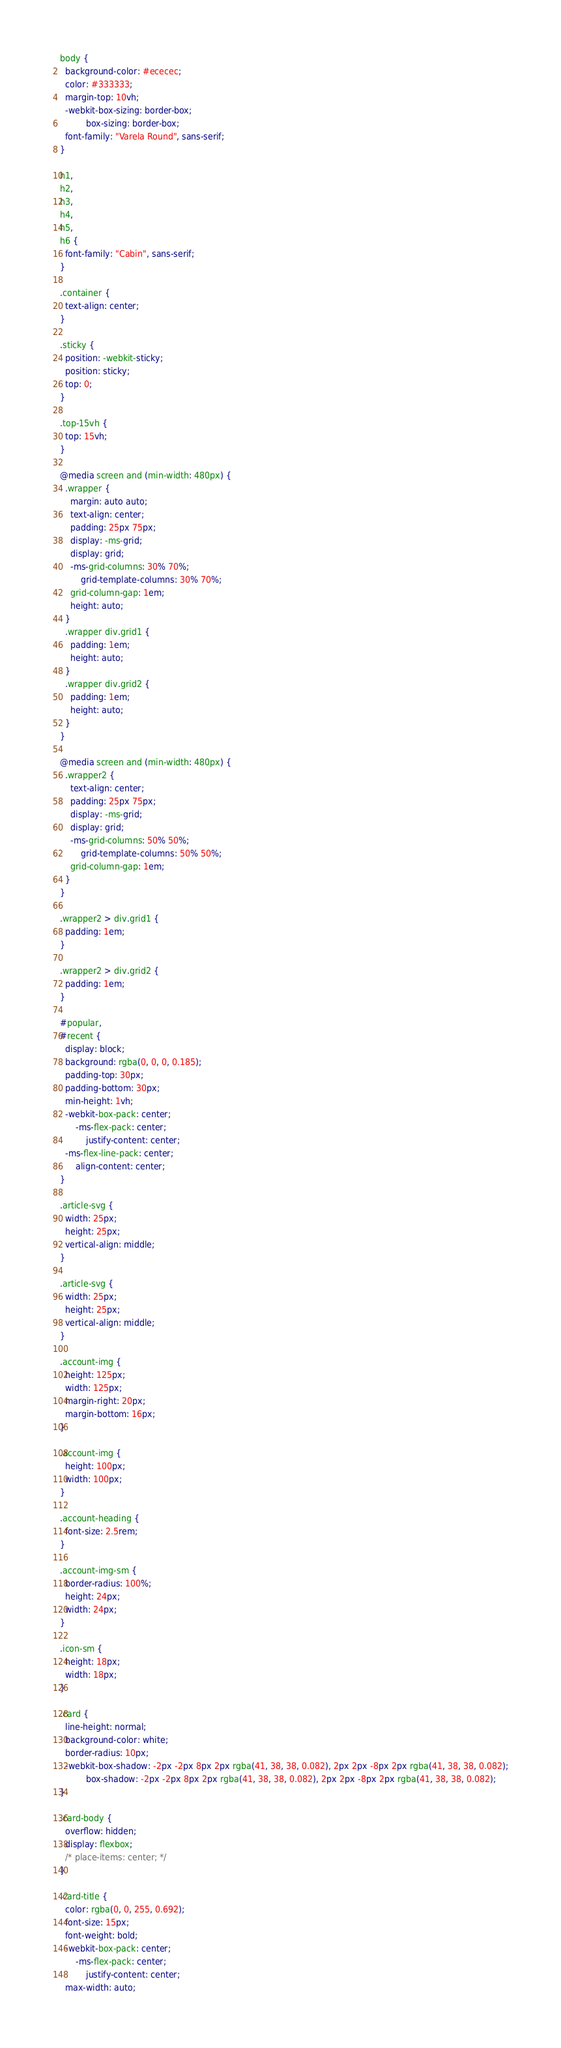Convert code to text. <code><loc_0><loc_0><loc_500><loc_500><_CSS_>body {
  background-color: #ececec;
  color: #333333;
  margin-top: 10vh;
  -webkit-box-sizing: border-box;
          box-sizing: border-box;
  font-family: "Varela Round", sans-serif;
}

h1,
h2,
h3,
h4,
h5,
h6 {
  font-family: "Cabin", sans-serif;
}

.container {
  text-align: center;
}

.sticky {
  position: -webkit-sticky;
  position: sticky;
  top: 0;
}

.top-15vh {
  top: 15vh;
}

@media screen and (min-width: 480px) {
  .wrapper {
    margin: auto auto;
    text-align: center;
    padding: 25px 75px;
    display: -ms-grid;
    display: grid;
    -ms-grid-columns: 30% 70%;
        grid-template-columns: 30% 70%;
    grid-column-gap: 1em;
    height: auto;
  }
  .wrapper div.grid1 {
    padding: 1em;
    height: auto;
  }
  .wrapper div.grid2 {
    padding: 1em;
    height: auto;
  }
}

@media screen and (min-width: 480px) {
  .wrapper2 {
    text-align: center;
    padding: 25px 75px;
    display: -ms-grid;
    display: grid;
    -ms-grid-columns: 50% 50%;
        grid-template-columns: 50% 50%;
    grid-column-gap: 1em;
  }
}

.wrapper2 > div.grid1 {
  padding: 1em;
}

.wrapper2 > div.grid2 {
  padding: 1em;
}

#popular,
#recent {
  display: block;
  background: rgba(0, 0, 0, 0.185);
  padding-top: 30px;
  padding-bottom: 30px;
  min-height: 1vh;
  -webkit-box-pack: center;
      -ms-flex-pack: center;
          justify-content: center;
  -ms-flex-line-pack: center;
      align-content: center;
}

.article-svg {
  width: 25px;
  height: 25px;
  vertical-align: middle;
}

.article-svg {
  width: 25px;
  height: 25px;
  vertical-align: middle;
}

.account-img {
  height: 125px;
  width: 125px;
  margin-right: 20px;
  margin-bottom: 16px;
}

.account-img {
  height: 100px;
  width: 100px;
}

.account-heading {
  font-size: 2.5rem;
}

.account-img-sm {
  border-radius: 100%;
  height: 24px;
  width: 24px;
}

.icon-sm {
  height: 18px;
  width: 18px;
}

.card {
  line-height: normal;
  background-color: white;
  border-radius: 10px;
  -webkit-box-shadow: -2px -2px 8px 2px rgba(41, 38, 38, 0.082), 2px 2px -8px 2px rgba(41, 38, 38, 0.082);
          box-shadow: -2px -2px 8px 2px rgba(41, 38, 38, 0.082), 2px 2px -8px 2px rgba(41, 38, 38, 0.082);
}

.card-body {
  overflow: hidden;
  display: flexbox;
  /* place-items: center; */
}

.card-title {
  color: rgba(0, 0, 255, 0.692);
  font-size: 15px;
  font-weight: bold;
  -webkit-box-pack: center;
      -ms-flex-pack: center;
          justify-content: center;
  max-width: auto;</code> 